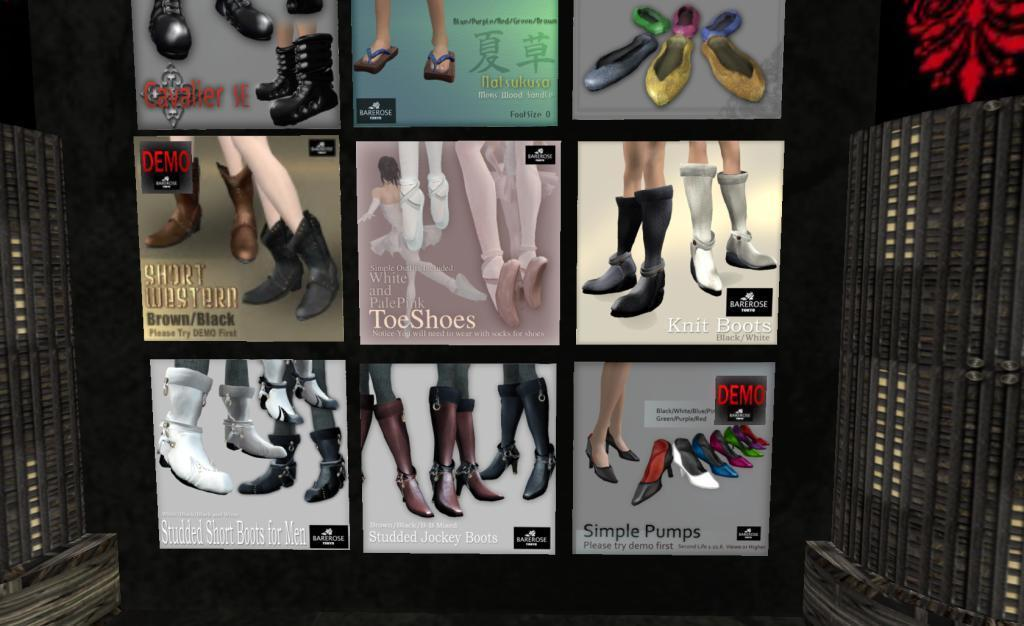What type of advertisements can be seen on the wall in the image? There are shoe ad posters on the wall in the image. What type of joke is being told by the muscle in the image? There is no muscle or joke present in the image; it only features shoe ad posters on the wall. 